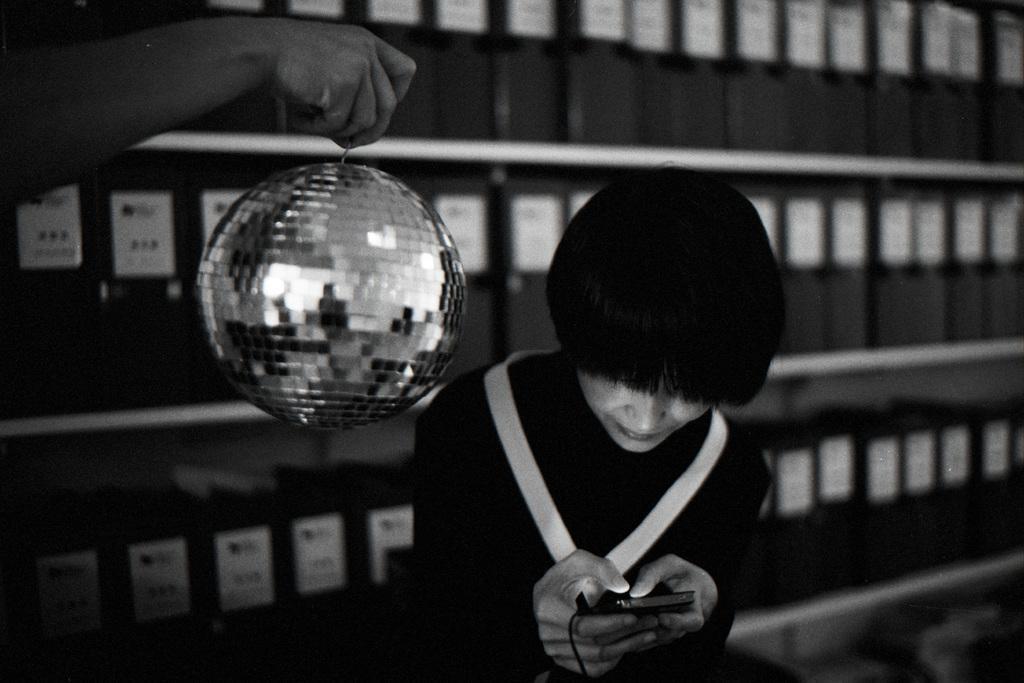Please provide a concise description of this image. In this image I can see a woman and I can see she is holding a phone. I can also see hand of a person is holding a disco ball. In the background I can see number of files on these shelves. I can also see this image is black and white in colour. 